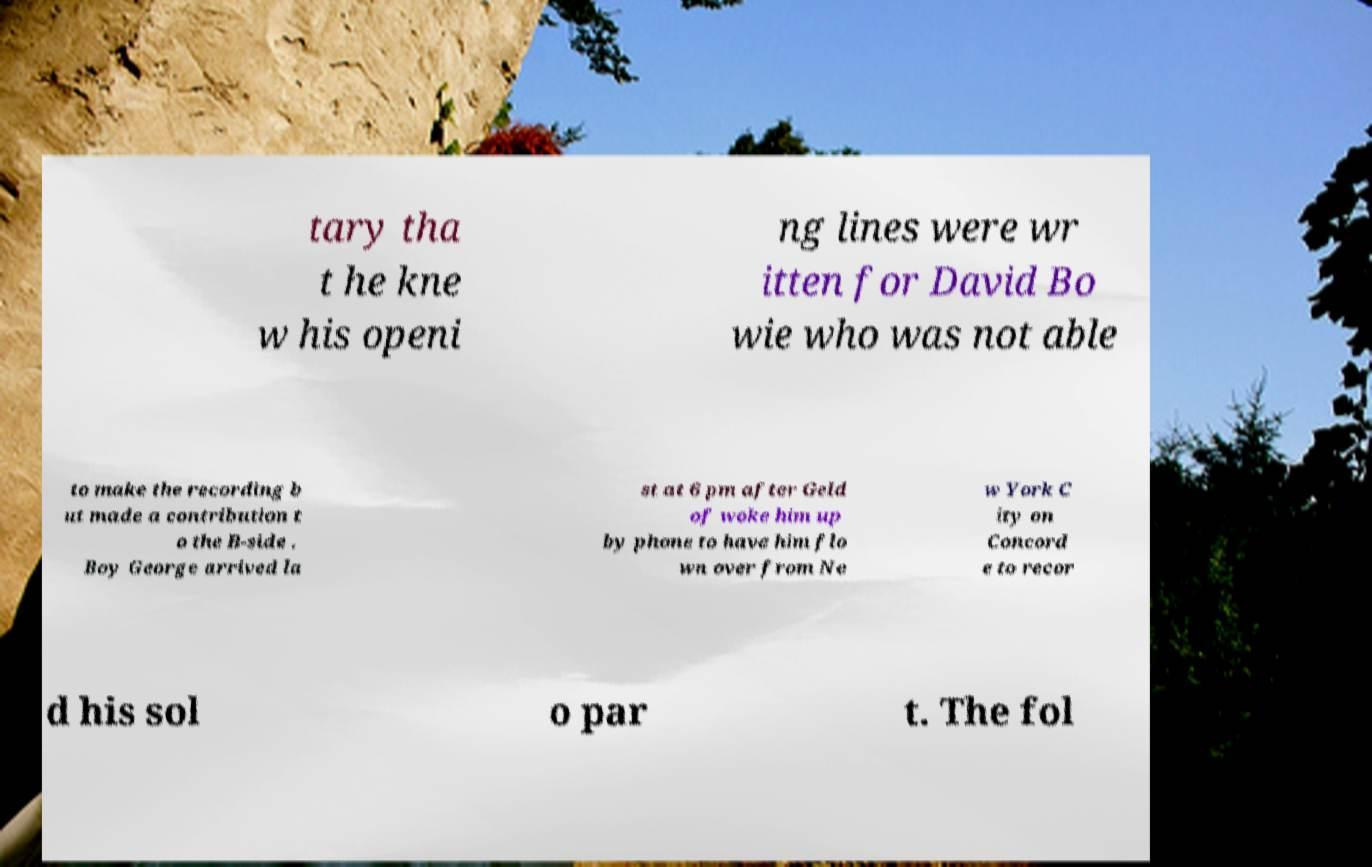Could you extract and type out the text from this image? tary tha t he kne w his openi ng lines were wr itten for David Bo wie who was not able to make the recording b ut made a contribution t o the B-side . Boy George arrived la st at 6 pm after Geld of woke him up by phone to have him flo wn over from Ne w York C ity on Concord e to recor d his sol o par t. The fol 